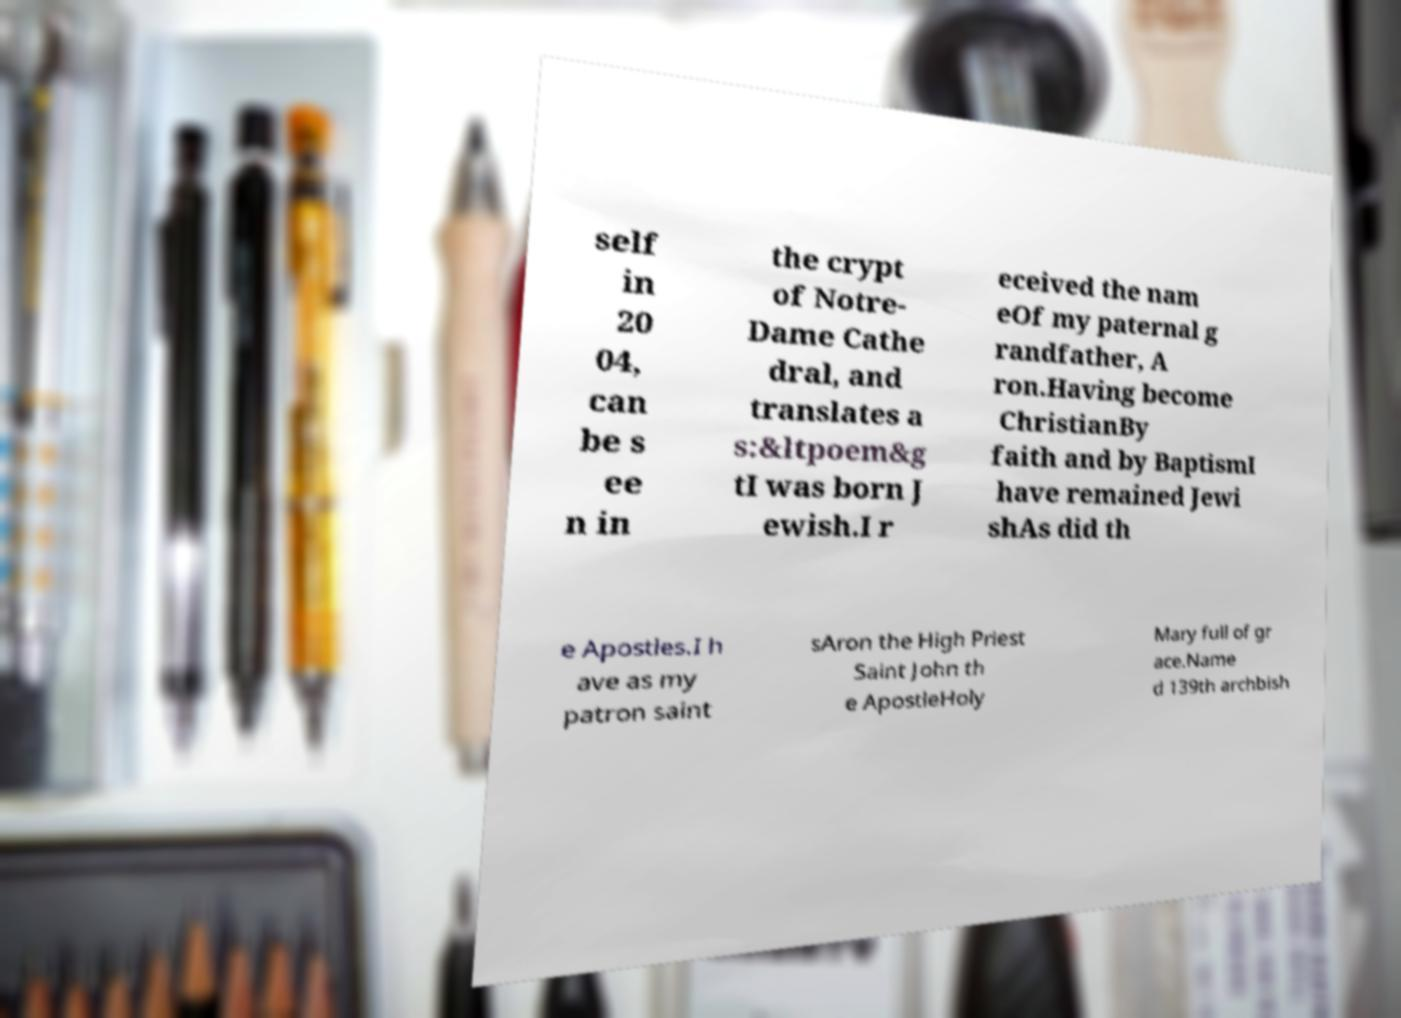Please identify and transcribe the text found in this image. self in 20 04, can be s ee n in the crypt of Notre- Dame Cathe dral, and translates a s:&ltpoem&g tI was born J ewish.I r eceived the nam eOf my paternal g randfather, A ron.Having become ChristianBy faith and by BaptismI have remained Jewi shAs did th e Apostles.I h ave as my patron saint sAron the High Priest Saint John th e ApostleHoly Mary full of gr ace.Name d 139th archbish 